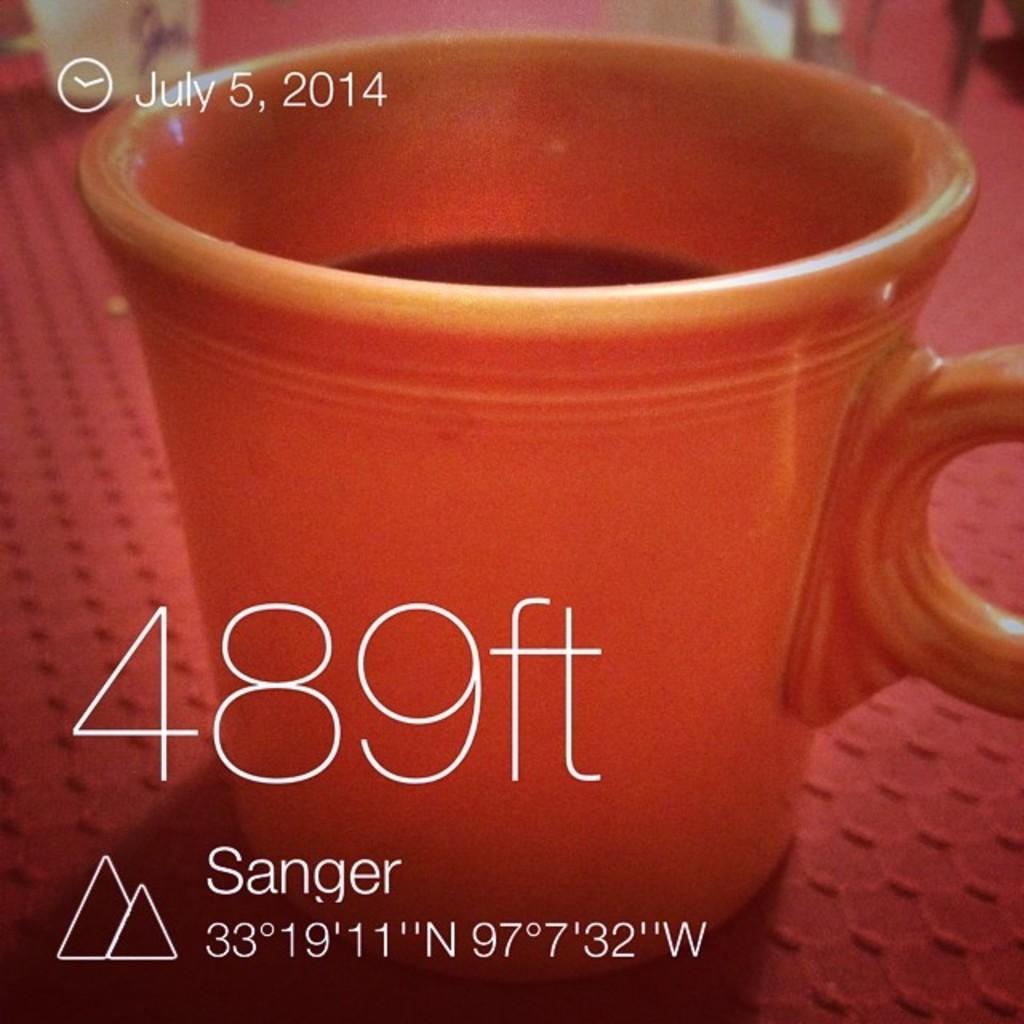What is the year in the photo?
Your answer should be compact. 2014. 